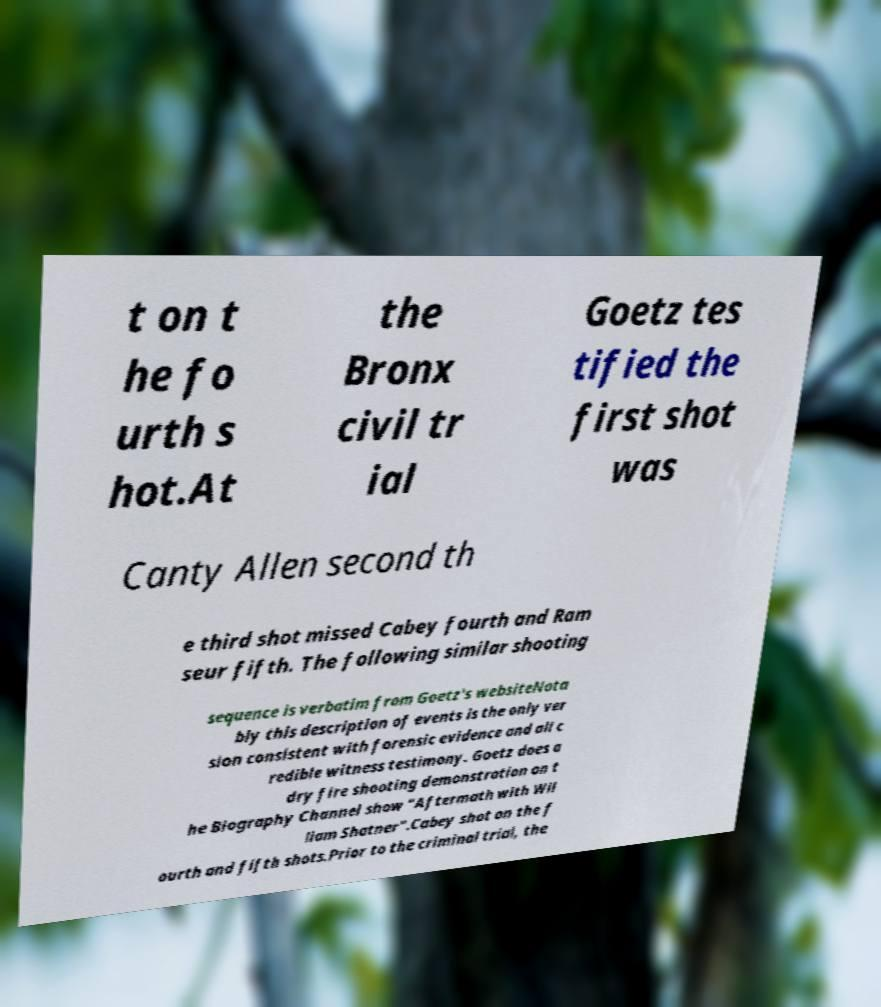There's text embedded in this image that I need extracted. Can you transcribe it verbatim? t on t he fo urth s hot.At the Bronx civil tr ial Goetz tes tified the first shot was Canty Allen second th e third shot missed Cabey fourth and Ram seur fifth. The following similar shooting sequence is verbatim from Goetz's websiteNota bly this description of events is the only ver sion consistent with forensic evidence and all c redible witness testimony. Goetz does a dry fire shooting demonstration on t he Biography Channel show "Aftermath with Wil liam Shatner".Cabey shot on the f ourth and fifth shots.Prior to the criminal trial, the 